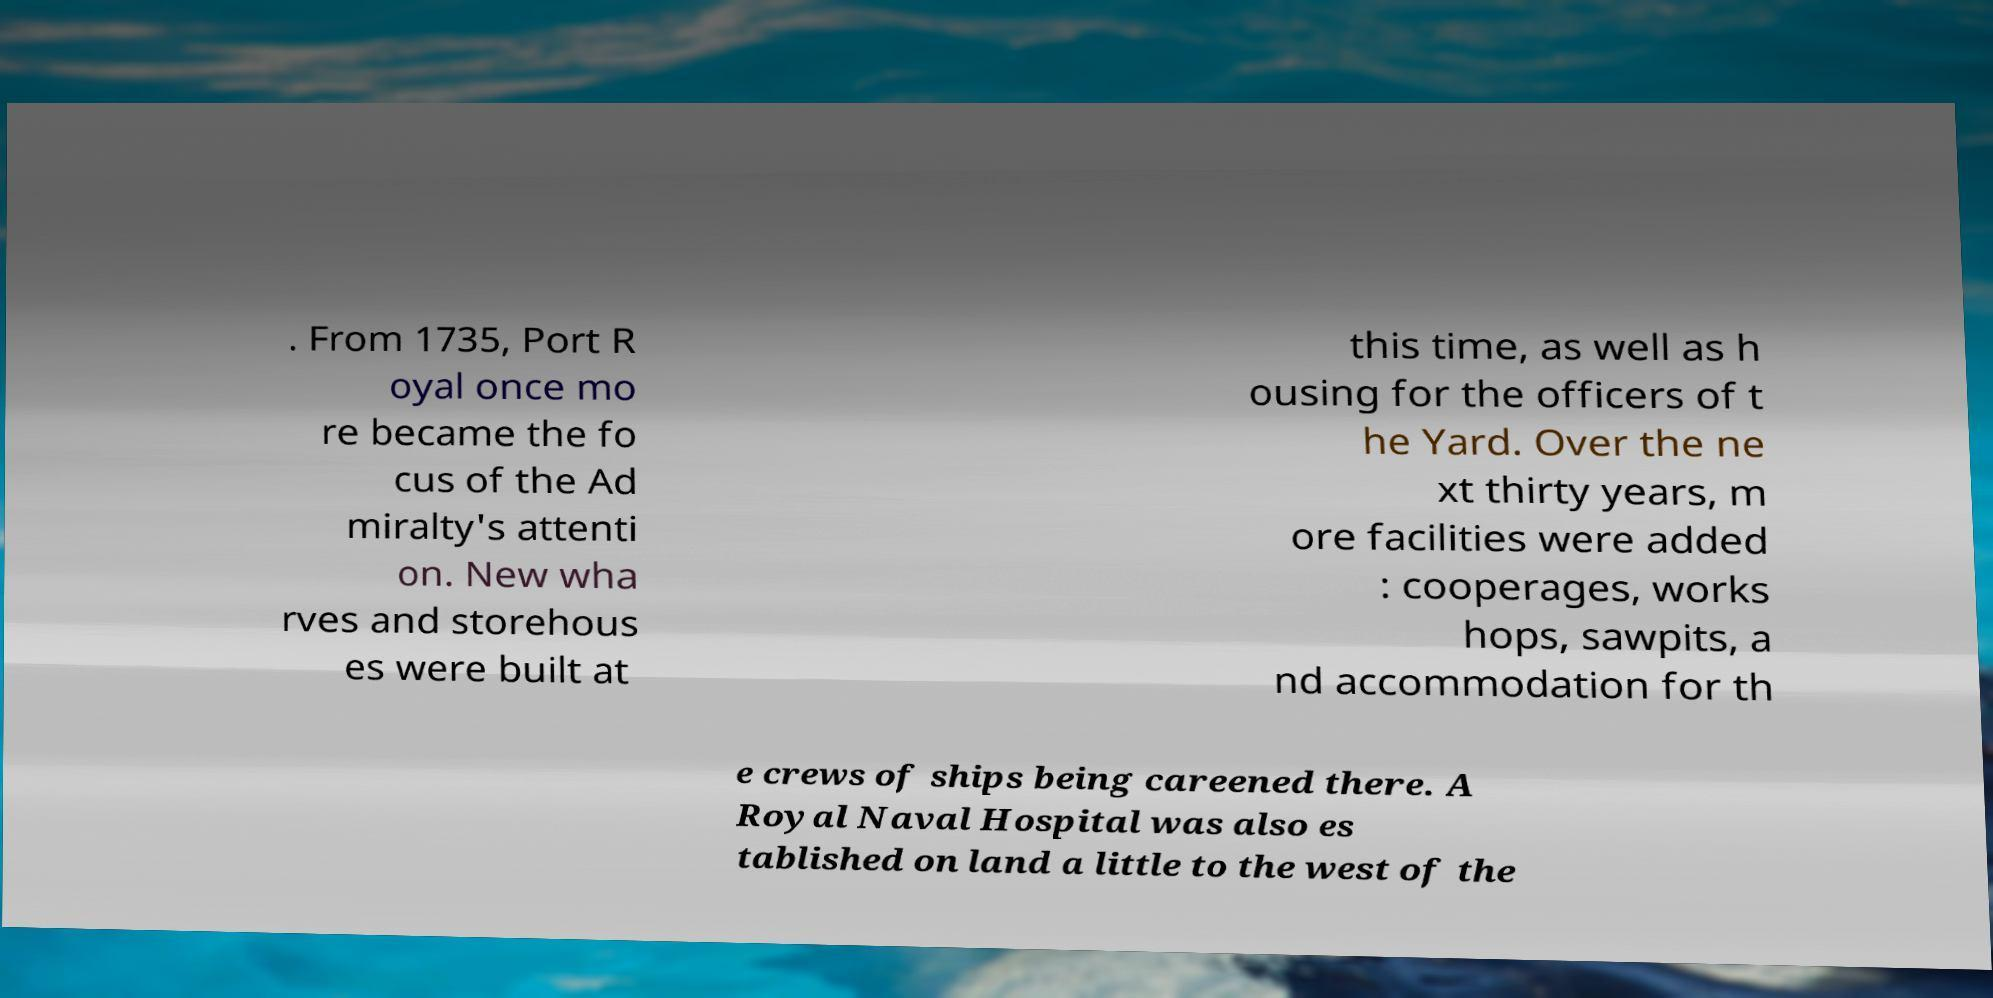Can you read and provide the text displayed in the image?This photo seems to have some interesting text. Can you extract and type it out for me? . From 1735, Port R oyal once mo re became the fo cus of the Ad miralty's attenti on. New wha rves and storehous es were built at this time, as well as h ousing for the officers of t he Yard. Over the ne xt thirty years, m ore facilities were added : cooperages, works hops, sawpits, a nd accommodation for th e crews of ships being careened there. A Royal Naval Hospital was also es tablished on land a little to the west of the 